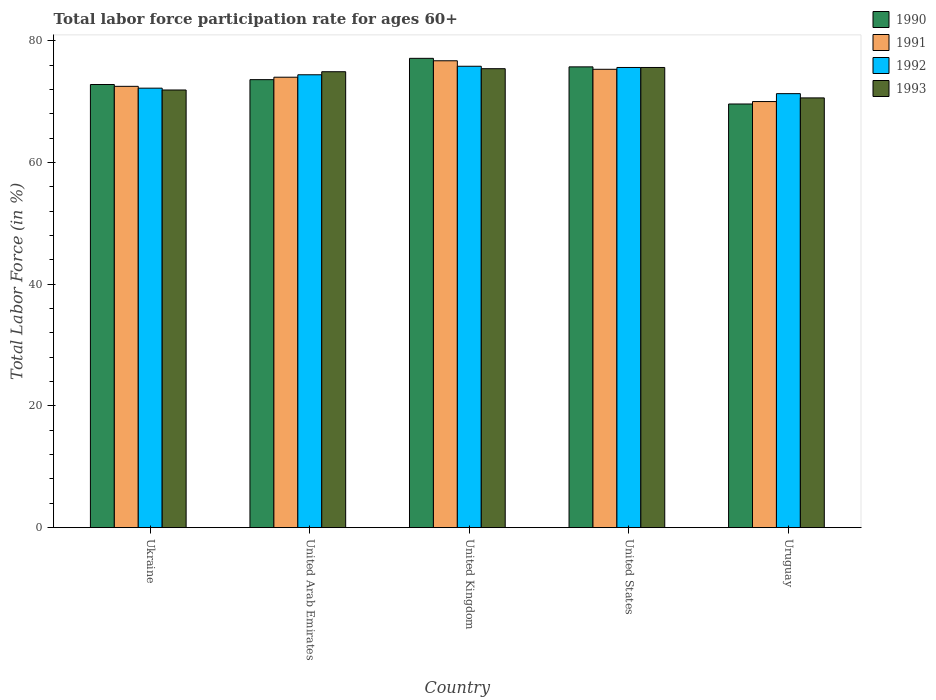How many different coloured bars are there?
Provide a succinct answer. 4. How many groups of bars are there?
Give a very brief answer. 5. Are the number of bars per tick equal to the number of legend labels?
Give a very brief answer. Yes. Are the number of bars on each tick of the X-axis equal?
Make the answer very short. Yes. How many bars are there on the 2nd tick from the left?
Your answer should be compact. 4. How many bars are there on the 3rd tick from the right?
Your answer should be very brief. 4. What is the label of the 3rd group of bars from the left?
Keep it short and to the point. United Kingdom. What is the labor force participation rate in 1992 in United Kingdom?
Your answer should be compact. 75.8. Across all countries, what is the maximum labor force participation rate in 1991?
Make the answer very short. 76.7. Across all countries, what is the minimum labor force participation rate in 1990?
Keep it short and to the point. 69.6. In which country was the labor force participation rate in 1993 minimum?
Make the answer very short. Uruguay. What is the total labor force participation rate in 1991 in the graph?
Your answer should be very brief. 368.5. What is the difference between the labor force participation rate in 1990 in Ukraine and that in United Arab Emirates?
Your answer should be very brief. -0.8. What is the difference between the labor force participation rate in 1992 in United Kingdom and the labor force participation rate in 1991 in United Arab Emirates?
Your answer should be very brief. 1.8. What is the average labor force participation rate in 1992 per country?
Make the answer very short. 73.86. What is the difference between the labor force participation rate of/in 1993 and labor force participation rate of/in 1990 in United States?
Provide a succinct answer. -0.1. In how many countries, is the labor force participation rate in 1993 greater than 16 %?
Offer a terse response. 5. What is the ratio of the labor force participation rate in 1990 in Ukraine to that in Uruguay?
Offer a very short reply. 1.05. Is the labor force participation rate in 1991 in United Arab Emirates less than that in United States?
Your response must be concise. Yes. Is the difference between the labor force participation rate in 1993 in Ukraine and United States greater than the difference between the labor force participation rate in 1990 in Ukraine and United States?
Offer a very short reply. No. What is the difference between the highest and the second highest labor force participation rate in 1993?
Your answer should be compact. -0.2. What is the difference between the highest and the lowest labor force participation rate in 1990?
Make the answer very short. 7.5. In how many countries, is the labor force participation rate in 1990 greater than the average labor force participation rate in 1990 taken over all countries?
Your answer should be very brief. 2. Is it the case that in every country, the sum of the labor force participation rate in 1992 and labor force participation rate in 1991 is greater than the sum of labor force participation rate in 1990 and labor force participation rate in 1993?
Your answer should be very brief. No. What does the 3rd bar from the right in United States represents?
Offer a very short reply. 1991. Is it the case that in every country, the sum of the labor force participation rate in 1990 and labor force participation rate in 1992 is greater than the labor force participation rate in 1991?
Provide a succinct answer. Yes. How many bars are there?
Your answer should be compact. 20. Are all the bars in the graph horizontal?
Ensure brevity in your answer.  No. How many countries are there in the graph?
Provide a short and direct response. 5. Does the graph contain any zero values?
Offer a very short reply. No. How are the legend labels stacked?
Ensure brevity in your answer.  Vertical. What is the title of the graph?
Provide a succinct answer. Total labor force participation rate for ages 60+. Does "2011" appear as one of the legend labels in the graph?
Provide a succinct answer. No. What is the label or title of the X-axis?
Offer a terse response. Country. What is the Total Labor Force (in %) of 1990 in Ukraine?
Make the answer very short. 72.8. What is the Total Labor Force (in %) in 1991 in Ukraine?
Provide a succinct answer. 72.5. What is the Total Labor Force (in %) of 1992 in Ukraine?
Provide a short and direct response. 72.2. What is the Total Labor Force (in %) in 1993 in Ukraine?
Offer a very short reply. 71.9. What is the Total Labor Force (in %) of 1990 in United Arab Emirates?
Provide a short and direct response. 73.6. What is the Total Labor Force (in %) of 1991 in United Arab Emirates?
Provide a succinct answer. 74. What is the Total Labor Force (in %) of 1992 in United Arab Emirates?
Your answer should be very brief. 74.4. What is the Total Labor Force (in %) of 1993 in United Arab Emirates?
Give a very brief answer. 74.9. What is the Total Labor Force (in %) of 1990 in United Kingdom?
Offer a very short reply. 77.1. What is the Total Labor Force (in %) of 1991 in United Kingdom?
Provide a short and direct response. 76.7. What is the Total Labor Force (in %) in 1992 in United Kingdom?
Make the answer very short. 75.8. What is the Total Labor Force (in %) in 1993 in United Kingdom?
Your answer should be very brief. 75.4. What is the Total Labor Force (in %) of 1990 in United States?
Give a very brief answer. 75.7. What is the Total Labor Force (in %) of 1991 in United States?
Your answer should be very brief. 75.3. What is the Total Labor Force (in %) in 1992 in United States?
Offer a terse response. 75.6. What is the Total Labor Force (in %) in 1993 in United States?
Provide a succinct answer. 75.6. What is the Total Labor Force (in %) in 1990 in Uruguay?
Give a very brief answer. 69.6. What is the Total Labor Force (in %) in 1992 in Uruguay?
Offer a terse response. 71.3. What is the Total Labor Force (in %) of 1993 in Uruguay?
Your response must be concise. 70.6. Across all countries, what is the maximum Total Labor Force (in %) in 1990?
Make the answer very short. 77.1. Across all countries, what is the maximum Total Labor Force (in %) of 1991?
Provide a succinct answer. 76.7. Across all countries, what is the maximum Total Labor Force (in %) of 1992?
Your answer should be compact. 75.8. Across all countries, what is the maximum Total Labor Force (in %) in 1993?
Your response must be concise. 75.6. Across all countries, what is the minimum Total Labor Force (in %) of 1990?
Offer a terse response. 69.6. Across all countries, what is the minimum Total Labor Force (in %) in 1991?
Offer a terse response. 70. Across all countries, what is the minimum Total Labor Force (in %) in 1992?
Provide a short and direct response. 71.3. Across all countries, what is the minimum Total Labor Force (in %) in 1993?
Give a very brief answer. 70.6. What is the total Total Labor Force (in %) in 1990 in the graph?
Give a very brief answer. 368.8. What is the total Total Labor Force (in %) in 1991 in the graph?
Your response must be concise. 368.5. What is the total Total Labor Force (in %) of 1992 in the graph?
Keep it short and to the point. 369.3. What is the total Total Labor Force (in %) of 1993 in the graph?
Provide a succinct answer. 368.4. What is the difference between the Total Labor Force (in %) of 1992 in Ukraine and that in United Arab Emirates?
Provide a short and direct response. -2.2. What is the difference between the Total Labor Force (in %) in 1993 in Ukraine and that in United Kingdom?
Offer a terse response. -3.5. What is the difference between the Total Labor Force (in %) in 1990 in Ukraine and that in United States?
Ensure brevity in your answer.  -2.9. What is the difference between the Total Labor Force (in %) of 1992 in Ukraine and that in United States?
Provide a succinct answer. -3.4. What is the difference between the Total Labor Force (in %) of 1993 in Ukraine and that in United States?
Your answer should be very brief. -3.7. What is the difference between the Total Labor Force (in %) in 1991 in Ukraine and that in Uruguay?
Offer a terse response. 2.5. What is the difference between the Total Labor Force (in %) of 1992 in Ukraine and that in Uruguay?
Your response must be concise. 0.9. What is the difference between the Total Labor Force (in %) in 1993 in Ukraine and that in Uruguay?
Keep it short and to the point. 1.3. What is the difference between the Total Labor Force (in %) in 1991 in United Arab Emirates and that in United Kingdom?
Give a very brief answer. -2.7. What is the difference between the Total Labor Force (in %) in 1992 in United Arab Emirates and that in United Kingdom?
Your answer should be compact. -1.4. What is the difference between the Total Labor Force (in %) of 1993 in United Arab Emirates and that in United Kingdom?
Give a very brief answer. -0.5. What is the difference between the Total Labor Force (in %) of 1992 in United Arab Emirates and that in United States?
Your response must be concise. -1.2. What is the difference between the Total Labor Force (in %) of 1993 in United Arab Emirates and that in United States?
Make the answer very short. -0.7. What is the difference between the Total Labor Force (in %) of 1991 in United Arab Emirates and that in Uruguay?
Provide a short and direct response. 4. What is the difference between the Total Labor Force (in %) in 1992 in United Arab Emirates and that in Uruguay?
Offer a terse response. 3.1. What is the difference between the Total Labor Force (in %) in 1992 in United Kingdom and that in United States?
Your answer should be very brief. 0.2. What is the difference between the Total Labor Force (in %) of 1990 in United Kingdom and that in Uruguay?
Keep it short and to the point. 7.5. What is the difference between the Total Labor Force (in %) in 1991 in United Kingdom and that in Uruguay?
Make the answer very short. 6.7. What is the difference between the Total Labor Force (in %) in 1992 in United Kingdom and that in Uruguay?
Provide a short and direct response. 4.5. What is the difference between the Total Labor Force (in %) of 1993 in United Kingdom and that in Uruguay?
Offer a very short reply. 4.8. What is the difference between the Total Labor Force (in %) of 1990 in United States and that in Uruguay?
Provide a short and direct response. 6.1. What is the difference between the Total Labor Force (in %) in 1992 in United States and that in Uruguay?
Provide a short and direct response. 4.3. What is the difference between the Total Labor Force (in %) in 1993 in United States and that in Uruguay?
Ensure brevity in your answer.  5. What is the difference between the Total Labor Force (in %) of 1990 in Ukraine and the Total Labor Force (in %) of 1991 in United Arab Emirates?
Offer a very short reply. -1.2. What is the difference between the Total Labor Force (in %) of 1990 in Ukraine and the Total Labor Force (in %) of 1993 in United Arab Emirates?
Provide a succinct answer. -2.1. What is the difference between the Total Labor Force (in %) of 1991 in Ukraine and the Total Labor Force (in %) of 1993 in United Arab Emirates?
Offer a terse response. -2.4. What is the difference between the Total Labor Force (in %) in 1990 in Ukraine and the Total Labor Force (in %) in 1991 in United Kingdom?
Ensure brevity in your answer.  -3.9. What is the difference between the Total Labor Force (in %) in 1990 in Ukraine and the Total Labor Force (in %) in 1992 in United Kingdom?
Keep it short and to the point. -3. What is the difference between the Total Labor Force (in %) in 1990 in Ukraine and the Total Labor Force (in %) in 1993 in United Kingdom?
Your answer should be very brief. -2.6. What is the difference between the Total Labor Force (in %) in 1991 in Ukraine and the Total Labor Force (in %) in 1992 in United Kingdom?
Your response must be concise. -3.3. What is the difference between the Total Labor Force (in %) of 1991 in Ukraine and the Total Labor Force (in %) of 1993 in United Kingdom?
Your answer should be compact. -2.9. What is the difference between the Total Labor Force (in %) of 1992 in Ukraine and the Total Labor Force (in %) of 1993 in United Kingdom?
Your answer should be compact. -3.2. What is the difference between the Total Labor Force (in %) of 1990 in Ukraine and the Total Labor Force (in %) of 1991 in United States?
Offer a very short reply. -2.5. What is the difference between the Total Labor Force (in %) of 1991 in Ukraine and the Total Labor Force (in %) of 1992 in United States?
Provide a succinct answer. -3.1. What is the difference between the Total Labor Force (in %) of 1992 in Ukraine and the Total Labor Force (in %) of 1993 in United States?
Provide a succinct answer. -3.4. What is the difference between the Total Labor Force (in %) in 1990 in Ukraine and the Total Labor Force (in %) in 1991 in Uruguay?
Provide a short and direct response. 2.8. What is the difference between the Total Labor Force (in %) in 1991 in Ukraine and the Total Labor Force (in %) in 1992 in Uruguay?
Provide a succinct answer. 1.2. What is the difference between the Total Labor Force (in %) in 1990 in United Arab Emirates and the Total Labor Force (in %) in 1992 in United Kingdom?
Offer a very short reply. -2.2. What is the difference between the Total Labor Force (in %) in 1990 in United Arab Emirates and the Total Labor Force (in %) in 1993 in United Kingdom?
Ensure brevity in your answer.  -1.8. What is the difference between the Total Labor Force (in %) in 1991 in United Arab Emirates and the Total Labor Force (in %) in 1993 in United Kingdom?
Make the answer very short. -1.4. What is the difference between the Total Labor Force (in %) in 1990 in United Arab Emirates and the Total Labor Force (in %) in 1991 in United States?
Keep it short and to the point. -1.7. What is the difference between the Total Labor Force (in %) of 1992 in United Arab Emirates and the Total Labor Force (in %) of 1993 in United States?
Make the answer very short. -1.2. What is the difference between the Total Labor Force (in %) in 1990 in United Arab Emirates and the Total Labor Force (in %) in 1993 in Uruguay?
Give a very brief answer. 3. What is the difference between the Total Labor Force (in %) of 1991 in United Arab Emirates and the Total Labor Force (in %) of 1992 in Uruguay?
Make the answer very short. 2.7. What is the difference between the Total Labor Force (in %) in 1991 in United Arab Emirates and the Total Labor Force (in %) in 1993 in Uruguay?
Offer a very short reply. 3.4. What is the difference between the Total Labor Force (in %) in 1990 in United Kingdom and the Total Labor Force (in %) in 1991 in United States?
Provide a short and direct response. 1.8. What is the difference between the Total Labor Force (in %) of 1990 in United Kingdom and the Total Labor Force (in %) of 1992 in United States?
Provide a succinct answer. 1.5. What is the difference between the Total Labor Force (in %) in 1991 in United Kingdom and the Total Labor Force (in %) in 1992 in United States?
Your answer should be compact. 1.1. What is the difference between the Total Labor Force (in %) of 1991 in United Kingdom and the Total Labor Force (in %) of 1992 in Uruguay?
Ensure brevity in your answer.  5.4. What is the difference between the Total Labor Force (in %) in 1991 in United States and the Total Labor Force (in %) in 1992 in Uruguay?
Ensure brevity in your answer.  4. What is the difference between the Total Labor Force (in %) of 1991 in United States and the Total Labor Force (in %) of 1993 in Uruguay?
Provide a short and direct response. 4.7. What is the average Total Labor Force (in %) in 1990 per country?
Offer a terse response. 73.76. What is the average Total Labor Force (in %) in 1991 per country?
Offer a terse response. 73.7. What is the average Total Labor Force (in %) in 1992 per country?
Keep it short and to the point. 73.86. What is the average Total Labor Force (in %) of 1993 per country?
Offer a terse response. 73.68. What is the difference between the Total Labor Force (in %) of 1990 and Total Labor Force (in %) of 1991 in Ukraine?
Your answer should be very brief. 0.3. What is the difference between the Total Labor Force (in %) in 1990 and Total Labor Force (in %) in 1993 in Ukraine?
Your answer should be very brief. 0.9. What is the difference between the Total Labor Force (in %) in 1991 and Total Labor Force (in %) in 1993 in Ukraine?
Your response must be concise. 0.6. What is the difference between the Total Labor Force (in %) in 1992 and Total Labor Force (in %) in 1993 in Ukraine?
Give a very brief answer. 0.3. What is the difference between the Total Labor Force (in %) in 1990 and Total Labor Force (in %) in 1991 in United Arab Emirates?
Your response must be concise. -0.4. What is the difference between the Total Labor Force (in %) in 1990 and Total Labor Force (in %) in 1992 in United Arab Emirates?
Provide a succinct answer. -0.8. What is the difference between the Total Labor Force (in %) in 1991 and Total Labor Force (in %) in 1993 in United Arab Emirates?
Provide a short and direct response. -0.9. What is the difference between the Total Labor Force (in %) in 1992 and Total Labor Force (in %) in 1993 in United Arab Emirates?
Ensure brevity in your answer.  -0.5. What is the difference between the Total Labor Force (in %) of 1990 and Total Labor Force (in %) of 1991 in United Kingdom?
Your answer should be very brief. 0.4. What is the difference between the Total Labor Force (in %) of 1990 and Total Labor Force (in %) of 1992 in United Kingdom?
Your answer should be very brief. 1.3. What is the difference between the Total Labor Force (in %) in 1990 and Total Labor Force (in %) in 1993 in United Kingdom?
Your answer should be very brief. 1.7. What is the difference between the Total Labor Force (in %) of 1992 and Total Labor Force (in %) of 1993 in United Kingdom?
Your response must be concise. 0.4. What is the difference between the Total Labor Force (in %) of 1990 and Total Labor Force (in %) of 1991 in United States?
Your answer should be very brief. 0.4. What is the difference between the Total Labor Force (in %) of 1990 and Total Labor Force (in %) of 1993 in United States?
Give a very brief answer. 0.1. What is the difference between the Total Labor Force (in %) in 1991 and Total Labor Force (in %) in 1992 in United States?
Your response must be concise. -0.3. What is the difference between the Total Labor Force (in %) of 1991 and Total Labor Force (in %) of 1993 in United States?
Offer a terse response. -0.3. What is the difference between the Total Labor Force (in %) in 1990 and Total Labor Force (in %) in 1991 in Uruguay?
Make the answer very short. -0.4. What is the difference between the Total Labor Force (in %) of 1990 and Total Labor Force (in %) of 1992 in Uruguay?
Offer a very short reply. -1.7. What is the difference between the Total Labor Force (in %) of 1990 and Total Labor Force (in %) of 1993 in Uruguay?
Your answer should be very brief. -1. What is the difference between the Total Labor Force (in %) of 1991 and Total Labor Force (in %) of 1992 in Uruguay?
Provide a short and direct response. -1.3. What is the difference between the Total Labor Force (in %) in 1992 and Total Labor Force (in %) in 1993 in Uruguay?
Make the answer very short. 0.7. What is the ratio of the Total Labor Force (in %) of 1990 in Ukraine to that in United Arab Emirates?
Your answer should be compact. 0.99. What is the ratio of the Total Labor Force (in %) of 1991 in Ukraine to that in United Arab Emirates?
Keep it short and to the point. 0.98. What is the ratio of the Total Labor Force (in %) in 1992 in Ukraine to that in United Arab Emirates?
Give a very brief answer. 0.97. What is the ratio of the Total Labor Force (in %) in 1993 in Ukraine to that in United Arab Emirates?
Your answer should be very brief. 0.96. What is the ratio of the Total Labor Force (in %) of 1990 in Ukraine to that in United Kingdom?
Give a very brief answer. 0.94. What is the ratio of the Total Labor Force (in %) in 1991 in Ukraine to that in United Kingdom?
Your answer should be very brief. 0.95. What is the ratio of the Total Labor Force (in %) in 1992 in Ukraine to that in United Kingdom?
Keep it short and to the point. 0.95. What is the ratio of the Total Labor Force (in %) in 1993 in Ukraine to that in United Kingdom?
Provide a succinct answer. 0.95. What is the ratio of the Total Labor Force (in %) of 1990 in Ukraine to that in United States?
Offer a very short reply. 0.96. What is the ratio of the Total Labor Force (in %) of 1991 in Ukraine to that in United States?
Your answer should be very brief. 0.96. What is the ratio of the Total Labor Force (in %) in 1992 in Ukraine to that in United States?
Ensure brevity in your answer.  0.95. What is the ratio of the Total Labor Force (in %) of 1993 in Ukraine to that in United States?
Give a very brief answer. 0.95. What is the ratio of the Total Labor Force (in %) in 1990 in Ukraine to that in Uruguay?
Make the answer very short. 1.05. What is the ratio of the Total Labor Force (in %) in 1991 in Ukraine to that in Uruguay?
Ensure brevity in your answer.  1.04. What is the ratio of the Total Labor Force (in %) in 1992 in Ukraine to that in Uruguay?
Ensure brevity in your answer.  1.01. What is the ratio of the Total Labor Force (in %) in 1993 in Ukraine to that in Uruguay?
Your answer should be compact. 1.02. What is the ratio of the Total Labor Force (in %) of 1990 in United Arab Emirates to that in United Kingdom?
Provide a succinct answer. 0.95. What is the ratio of the Total Labor Force (in %) of 1991 in United Arab Emirates to that in United Kingdom?
Provide a short and direct response. 0.96. What is the ratio of the Total Labor Force (in %) in 1992 in United Arab Emirates to that in United Kingdom?
Ensure brevity in your answer.  0.98. What is the ratio of the Total Labor Force (in %) in 1993 in United Arab Emirates to that in United Kingdom?
Your answer should be compact. 0.99. What is the ratio of the Total Labor Force (in %) in 1990 in United Arab Emirates to that in United States?
Provide a short and direct response. 0.97. What is the ratio of the Total Labor Force (in %) of 1991 in United Arab Emirates to that in United States?
Offer a terse response. 0.98. What is the ratio of the Total Labor Force (in %) of 1992 in United Arab Emirates to that in United States?
Ensure brevity in your answer.  0.98. What is the ratio of the Total Labor Force (in %) in 1990 in United Arab Emirates to that in Uruguay?
Provide a succinct answer. 1.06. What is the ratio of the Total Labor Force (in %) in 1991 in United Arab Emirates to that in Uruguay?
Provide a short and direct response. 1.06. What is the ratio of the Total Labor Force (in %) in 1992 in United Arab Emirates to that in Uruguay?
Provide a short and direct response. 1.04. What is the ratio of the Total Labor Force (in %) in 1993 in United Arab Emirates to that in Uruguay?
Provide a succinct answer. 1.06. What is the ratio of the Total Labor Force (in %) of 1990 in United Kingdom to that in United States?
Ensure brevity in your answer.  1.02. What is the ratio of the Total Labor Force (in %) of 1991 in United Kingdom to that in United States?
Your response must be concise. 1.02. What is the ratio of the Total Labor Force (in %) in 1992 in United Kingdom to that in United States?
Provide a succinct answer. 1. What is the ratio of the Total Labor Force (in %) in 1990 in United Kingdom to that in Uruguay?
Offer a very short reply. 1.11. What is the ratio of the Total Labor Force (in %) of 1991 in United Kingdom to that in Uruguay?
Your answer should be very brief. 1.1. What is the ratio of the Total Labor Force (in %) in 1992 in United Kingdom to that in Uruguay?
Provide a short and direct response. 1.06. What is the ratio of the Total Labor Force (in %) in 1993 in United Kingdom to that in Uruguay?
Make the answer very short. 1.07. What is the ratio of the Total Labor Force (in %) in 1990 in United States to that in Uruguay?
Provide a short and direct response. 1.09. What is the ratio of the Total Labor Force (in %) in 1991 in United States to that in Uruguay?
Offer a very short reply. 1.08. What is the ratio of the Total Labor Force (in %) of 1992 in United States to that in Uruguay?
Provide a succinct answer. 1.06. What is the ratio of the Total Labor Force (in %) in 1993 in United States to that in Uruguay?
Provide a succinct answer. 1.07. What is the difference between the highest and the second highest Total Labor Force (in %) in 1991?
Your response must be concise. 1.4. What is the difference between the highest and the second highest Total Labor Force (in %) of 1992?
Provide a short and direct response. 0.2. What is the difference between the highest and the lowest Total Labor Force (in %) of 1990?
Ensure brevity in your answer.  7.5. What is the difference between the highest and the lowest Total Labor Force (in %) of 1992?
Give a very brief answer. 4.5. 